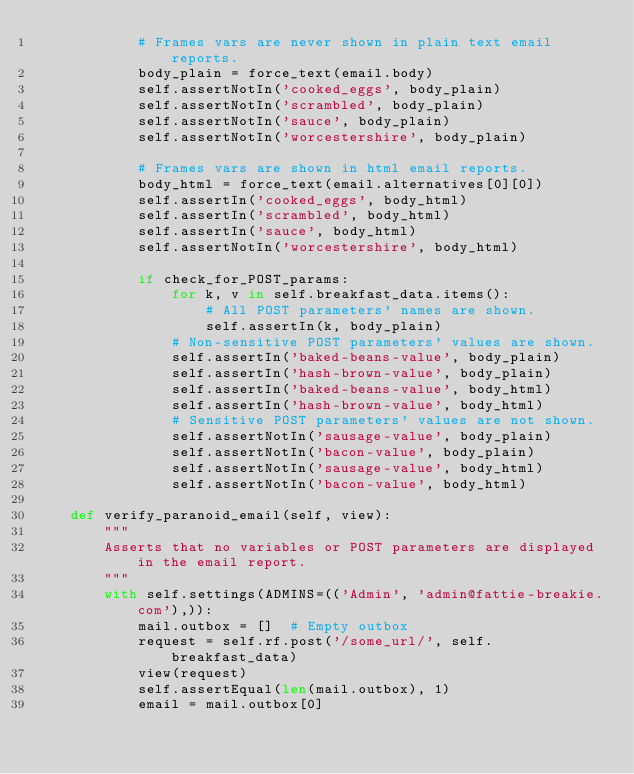<code> <loc_0><loc_0><loc_500><loc_500><_Python_>            # Frames vars are never shown in plain text email reports.
            body_plain = force_text(email.body)
            self.assertNotIn('cooked_eggs', body_plain)
            self.assertNotIn('scrambled', body_plain)
            self.assertNotIn('sauce', body_plain)
            self.assertNotIn('worcestershire', body_plain)

            # Frames vars are shown in html email reports.
            body_html = force_text(email.alternatives[0][0])
            self.assertIn('cooked_eggs', body_html)
            self.assertIn('scrambled', body_html)
            self.assertIn('sauce', body_html)
            self.assertNotIn('worcestershire', body_html)

            if check_for_POST_params:
                for k, v in self.breakfast_data.items():
                    # All POST parameters' names are shown.
                    self.assertIn(k, body_plain)
                # Non-sensitive POST parameters' values are shown.
                self.assertIn('baked-beans-value', body_plain)
                self.assertIn('hash-brown-value', body_plain)
                self.assertIn('baked-beans-value', body_html)
                self.assertIn('hash-brown-value', body_html)
                # Sensitive POST parameters' values are not shown.
                self.assertNotIn('sausage-value', body_plain)
                self.assertNotIn('bacon-value', body_plain)
                self.assertNotIn('sausage-value', body_html)
                self.assertNotIn('bacon-value', body_html)

    def verify_paranoid_email(self, view):
        """
        Asserts that no variables or POST parameters are displayed in the email report.
        """
        with self.settings(ADMINS=(('Admin', 'admin@fattie-breakie.com'),)):
            mail.outbox = []  # Empty outbox
            request = self.rf.post('/some_url/', self.breakfast_data)
            view(request)
            self.assertEqual(len(mail.outbox), 1)
            email = mail.outbox[0]</code> 